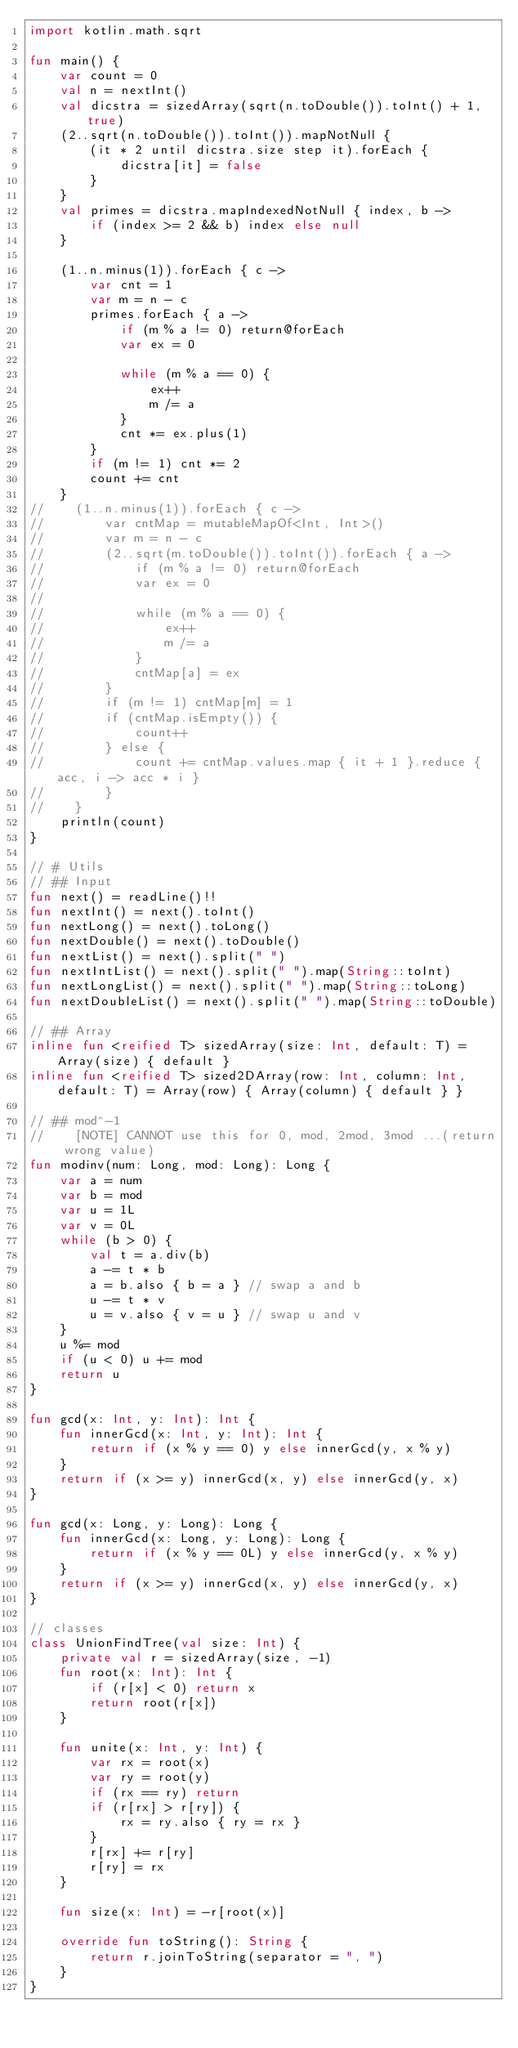<code> <loc_0><loc_0><loc_500><loc_500><_Kotlin_>import kotlin.math.sqrt

fun main() {
    var count = 0
    val n = nextInt()
    val dicstra = sizedArray(sqrt(n.toDouble()).toInt() + 1, true)
    (2..sqrt(n.toDouble()).toInt()).mapNotNull {
        (it * 2 until dicstra.size step it).forEach {
            dicstra[it] = false
        }
    }
    val primes = dicstra.mapIndexedNotNull { index, b ->
        if (index >= 2 && b) index else null
    }

    (1..n.minus(1)).forEach { c ->
        var cnt = 1
        var m = n - c
        primes.forEach { a ->
            if (m % a != 0) return@forEach
            var ex = 0

            while (m % a == 0) {
                ex++
                m /= a
            }
            cnt *= ex.plus(1)
        }
        if (m != 1) cnt *= 2
        count += cnt
    }
//    (1..n.minus(1)).forEach { c ->
//        var cntMap = mutableMapOf<Int, Int>()
//        var m = n - c
//        (2..sqrt(m.toDouble()).toInt()).forEach { a ->
//            if (m % a != 0) return@forEach
//            var ex = 0
//
//            while (m % a == 0) {
//                ex++
//                m /= a
//            }
//            cntMap[a] = ex
//        }
//        if (m != 1) cntMap[m] = 1
//        if (cntMap.isEmpty()) {
//            count++
//        } else {
//            count += cntMap.values.map { it + 1 }.reduce { acc, i -> acc * i }
//        }
//    }
    println(count)
}

// # Utils
// ## Input
fun next() = readLine()!!
fun nextInt() = next().toInt()
fun nextLong() = next().toLong()
fun nextDouble() = next().toDouble()
fun nextList() = next().split(" ")
fun nextIntList() = next().split(" ").map(String::toInt)
fun nextLongList() = next().split(" ").map(String::toLong)
fun nextDoubleList() = next().split(" ").map(String::toDouble)

// ## Array
inline fun <reified T> sizedArray(size: Int, default: T) = Array(size) { default }
inline fun <reified T> sized2DArray(row: Int, column: Int, default: T) = Array(row) { Array(column) { default } }

// ## mod^-1
//    [NOTE] CANNOT use this for 0, mod, 2mod, 3mod ...(return wrong value)
fun modinv(num: Long, mod: Long): Long {
    var a = num
    var b = mod
    var u = 1L
    var v = 0L
    while (b > 0) {
        val t = a.div(b)
        a -= t * b
        a = b.also { b = a } // swap a and b
        u -= t * v
        u = v.also { v = u } // swap u and v
    }
    u %= mod
    if (u < 0) u += mod
    return u
}

fun gcd(x: Int, y: Int): Int {
    fun innerGcd(x: Int, y: Int): Int {
        return if (x % y == 0) y else innerGcd(y, x % y)
    }
    return if (x >= y) innerGcd(x, y) else innerGcd(y, x)
}

fun gcd(x: Long, y: Long): Long {
    fun innerGcd(x: Long, y: Long): Long {
        return if (x % y == 0L) y else innerGcd(y, x % y)
    }
    return if (x >= y) innerGcd(x, y) else innerGcd(y, x)
}

// classes
class UnionFindTree(val size: Int) {
    private val r = sizedArray(size, -1)
    fun root(x: Int): Int {
        if (r[x] < 0) return x
        return root(r[x])
    }

    fun unite(x: Int, y: Int) {
        var rx = root(x)
        var ry = root(y)
        if (rx == ry) return
        if (r[rx] > r[ry]) {
            rx = ry.also { ry = rx }
        }
        r[rx] += r[ry]
        r[ry] = rx
    }

    fun size(x: Int) = -r[root(x)]

    override fun toString(): String {
        return r.joinToString(separator = ", ")
    }
}</code> 